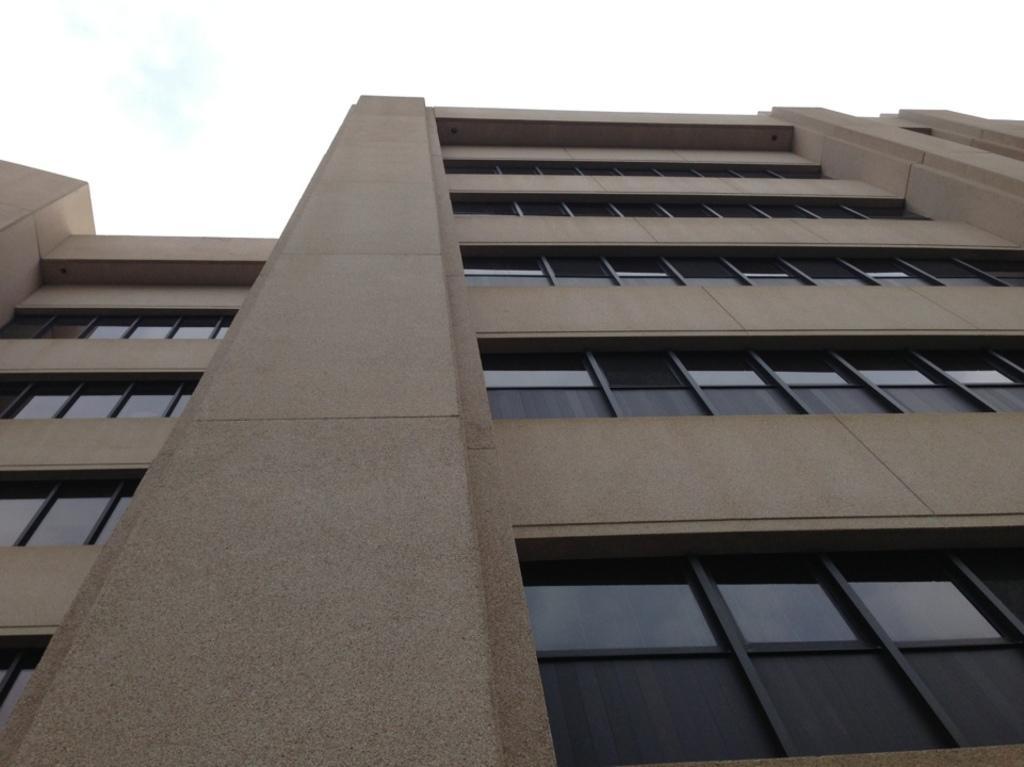In one or two sentences, can you explain what this image depicts? Here there is a building with the windows made of glass. 